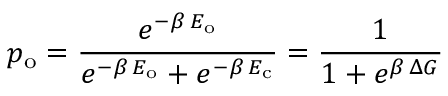Convert formula to latex. <formula><loc_0><loc_0><loc_500><loc_500>p _ { o } = \frac { e ^ { - \beta \, E _ { o } } } { e ^ { - \beta \, E _ { o } } + e ^ { - \beta \, E _ { c } } } = \frac { 1 } { 1 + e ^ { \beta \, \Delta G } }</formula> 